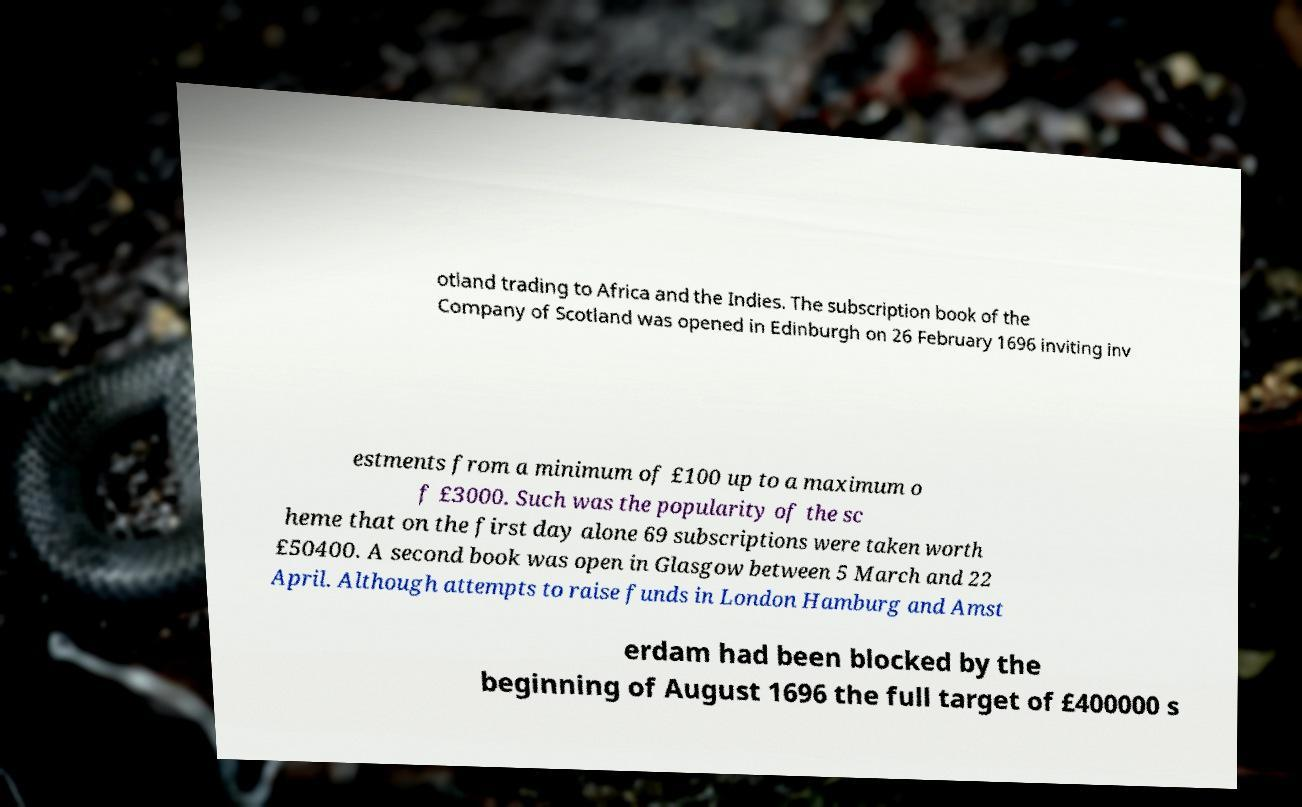Could you extract and type out the text from this image? otland trading to Africa and the Indies. The subscription book of the Company of Scotland was opened in Edinburgh on 26 February 1696 inviting inv estments from a minimum of £100 up to a maximum o f £3000. Such was the popularity of the sc heme that on the first day alone 69 subscriptions were taken worth £50400. A second book was open in Glasgow between 5 March and 22 April. Although attempts to raise funds in London Hamburg and Amst erdam had been blocked by the beginning of August 1696 the full target of £400000 s 